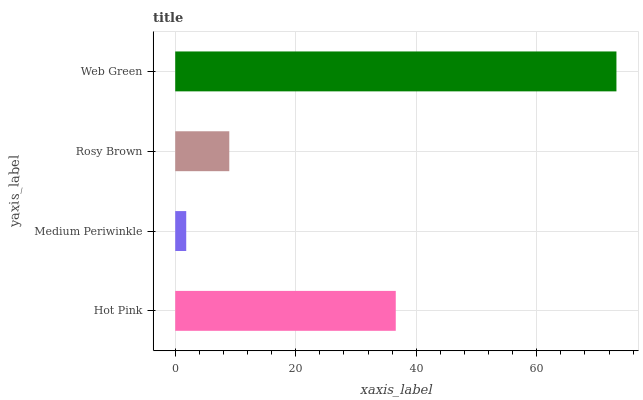Is Medium Periwinkle the minimum?
Answer yes or no. Yes. Is Web Green the maximum?
Answer yes or no. Yes. Is Rosy Brown the minimum?
Answer yes or no. No. Is Rosy Brown the maximum?
Answer yes or no. No. Is Rosy Brown greater than Medium Periwinkle?
Answer yes or no. Yes. Is Medium Periwinkle less than Rosy Brown?
Answer yes or no. Yes. Is Medium Periwinkle greater than Rosy Brown?
Answer yes or no. No. Is Rosy Brown less than Medium Periwinkle?
Answer yes or no. No. Is Hot Pink the high median?
Answer yes or no. Yes. Is Rosy Brown the low median?
Answer yes or no. Yes. Is Web Green the high median?
Answer yes or no. No. Is Medium Periwinkle the low median?
Answer yes or no. No. 